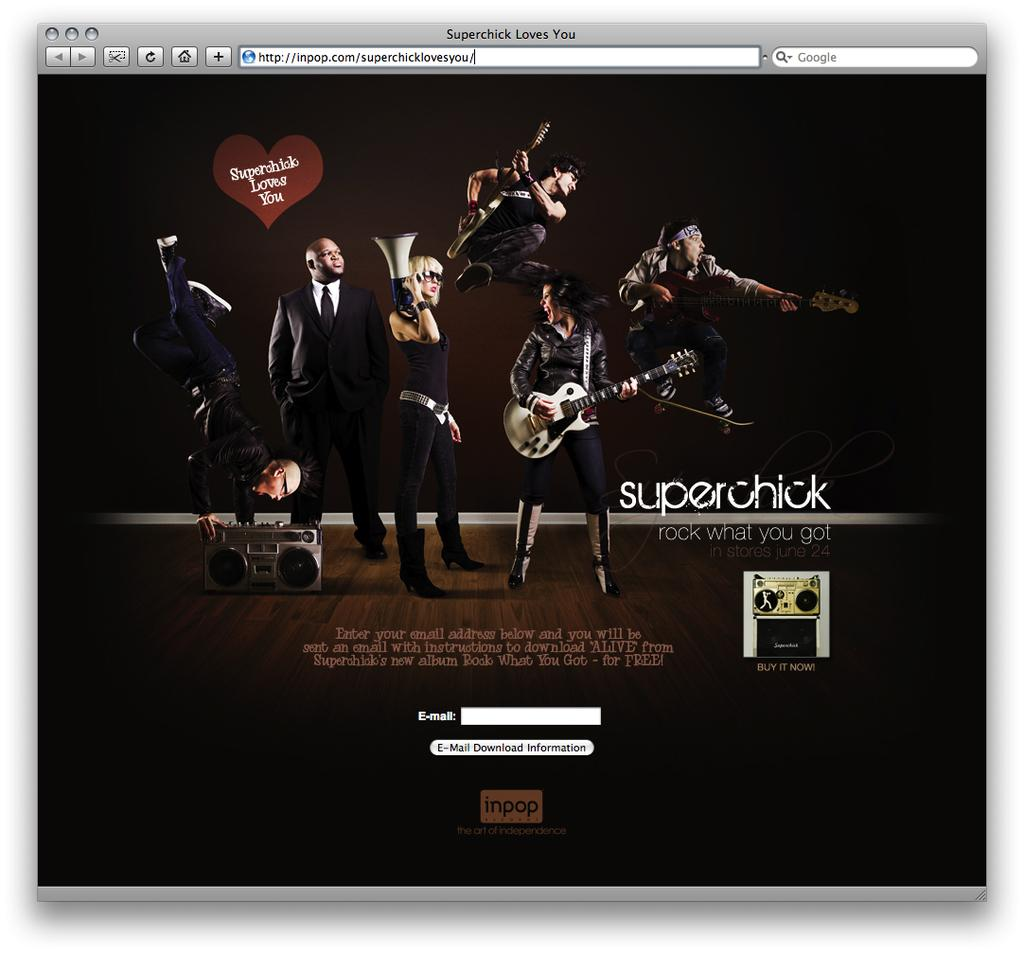What type of page is displayed in the image? There is a login page in the image. What can be seen on the login page? The login page contains an image of people playing musical instruments. Is there any text or label associated with the image? Yes, the name "super chick" is present beside the image. What type of vegetable is used as a key to unlock the login page? There is no vegetable or key present in the image; it is a login page with an image of people playing musical instruments and the label "super chick." 